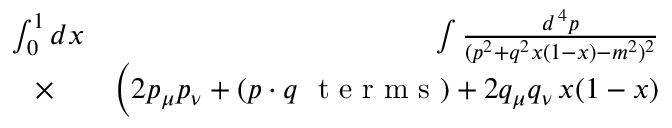Convert formula to latex. <formula><loc_0><loc_0><loc_500><loc_500>\begin{array} { r l r } { \int _ { 0 } ^ { 1 } d x \, } & { \int { \frac { d ^ { \, 4 } p } { ( p ^ { 2 } + q ^ { 2 } x ( 1 - x ) - m ^ { 2 } ) ^ { 2 } } } } \\ { \times } & { \Big ( 2 p _ { \mu } p _ { \nu } + ( p \cdot q \ t e r m s ) + 2 q _ { \mu } q _ { \nu } \, x ( 1 - x ) } \end{array}</formula> 